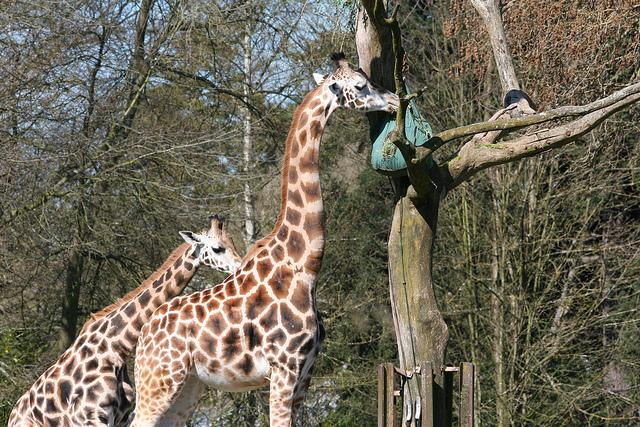What distinguishes the animals above from the rest? long neck 